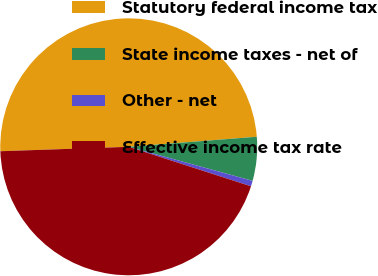Convert chart to OTSL. <chart><loc_0><loc_0><loc_500><loc_500><pie_chart><fcel>Statutory federal income tax<fcel>State income taxes - net of<fcel>Other - net<fcel>Effective income tax rate<nl><fcel>49.3%<fcel>5.52%<fcel>0.7%<fcel>44.48%<nl></chart> 